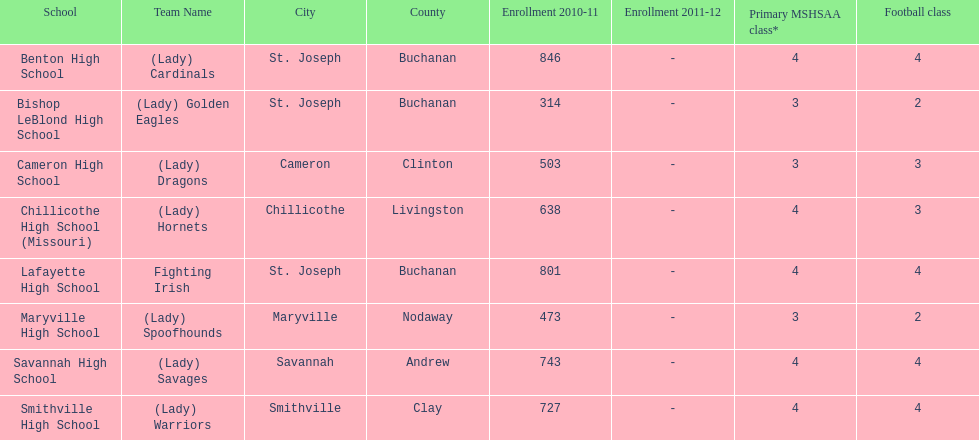Which school has the least amount of student enrollment between 2010-2011 and 2011-2012? Bishop LeBlond High School. 